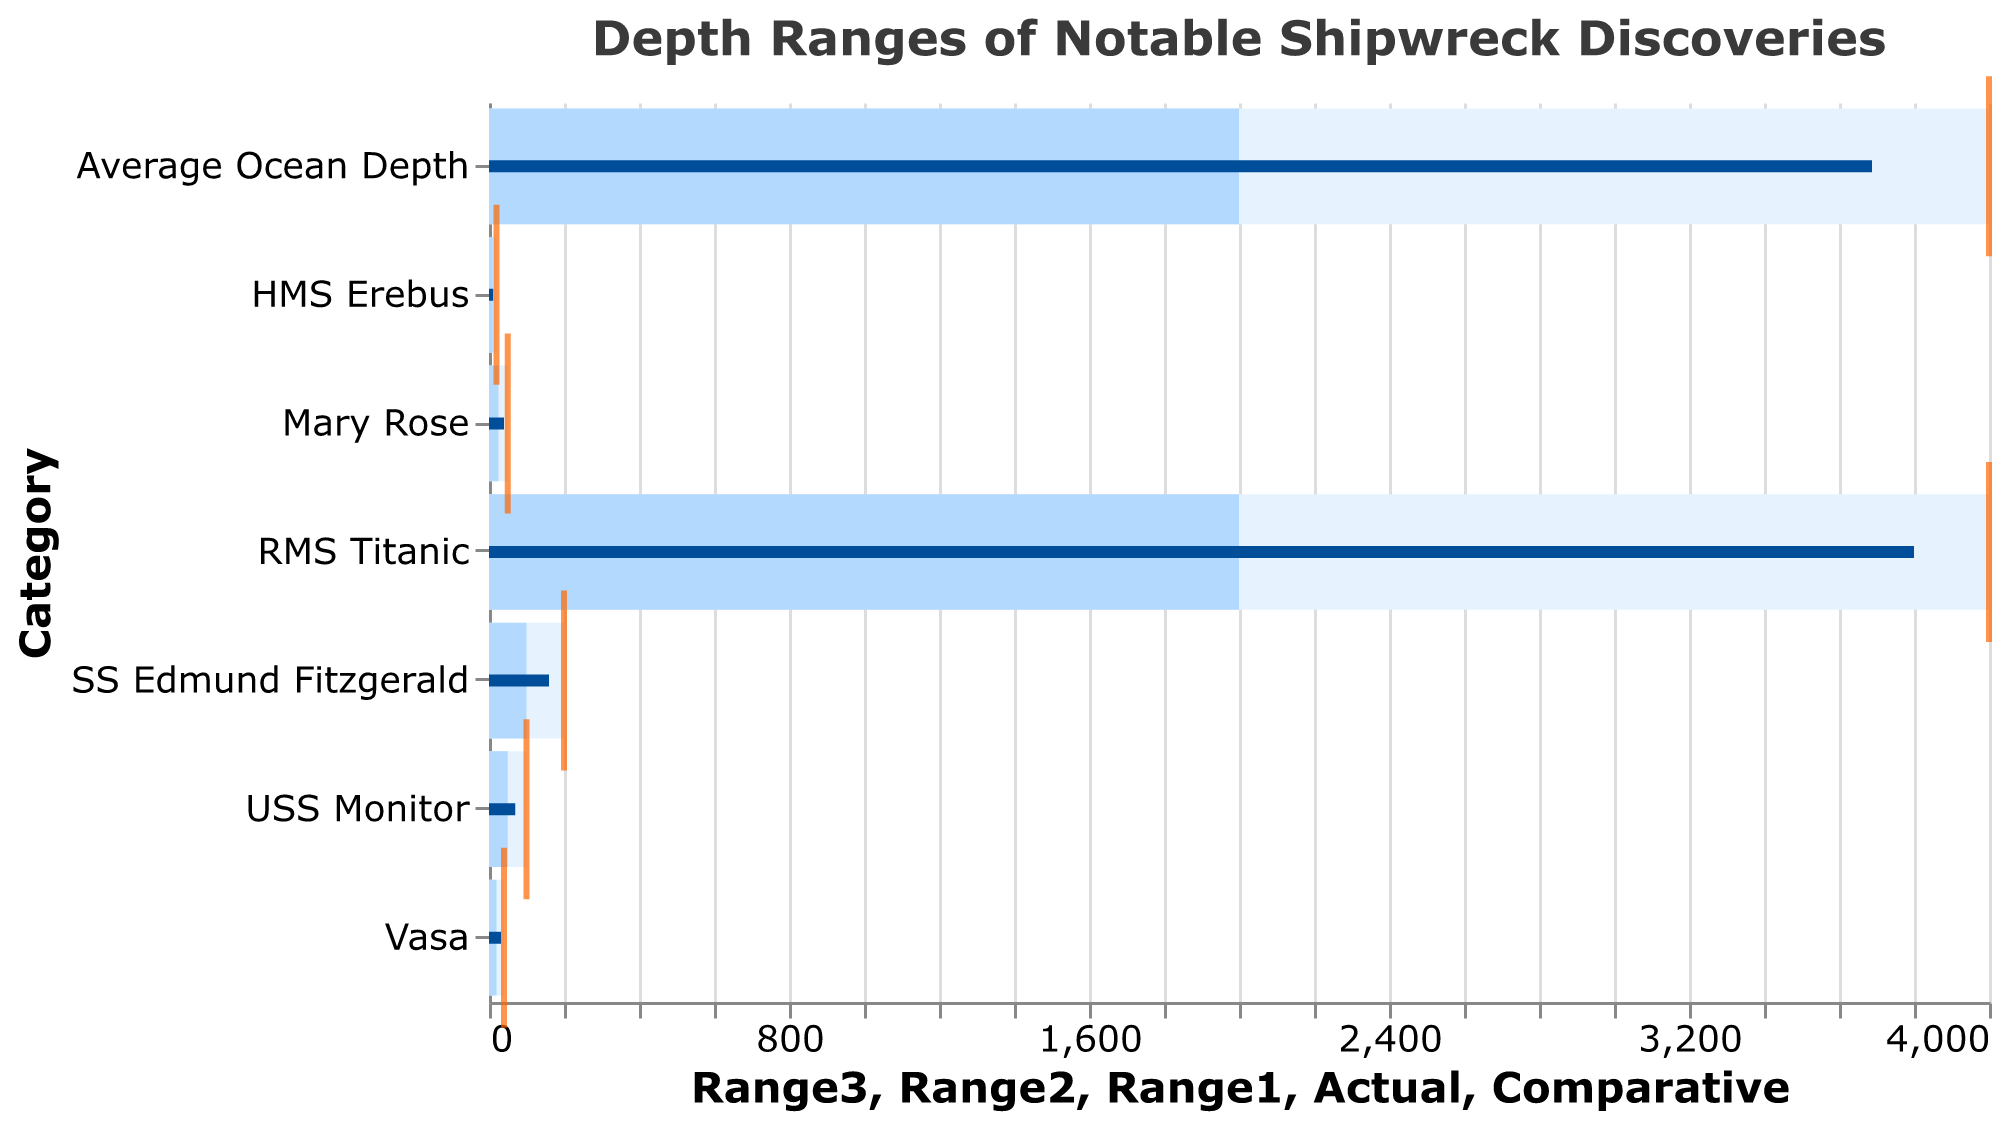What is the title of the figure? The title of the figure is displayed at the top and describes the content being visualized.
Answer: Depth Ranges of Notable Shipwreck Discoveries What is the actual depth of the RMS Titanic's wreck? Look for the "RMS Titanic" category in the figure and check the bar labeled for actual depth.
Answer: 3800 Which shipwreck has the shallowest actual depth? Compare the actual depths of all shipwrecks and find the minimum value. The HMS Erebus has the smallest bar representing its depth.
Answer: HMS Erebus How does the actual depth of the Vasa compare to its comparative depth? Locate the "Vasa" entry and compare the bars. The actual bar reaches 32, and the comparative bar (orange tick) reaches 40.
Answer: The actual depth of the Vasa is 8 meters less than its comparative depth What is the range of depths for the SS Edmund Fitzgerald? Identify the "SS Edmund Fitzgerald" and look at the bars. The range is represented by the lightest blue bar, spanning from 0 to 200 meters.
Answer: 0 to 200 meters Which shipwreck lies deeper than the average ocean depth? Compare the individual shipwreck bars to the "Average Ocean Depth" bar. The "RMS Titanic" has an actual depth (3800) greater than the average ocean depth (3688).
Answer: RMS Titanic For shipwrecks with a lower comparative depth than the RMS Titanic's actual depth, what is the common characteristic? Look for shipwrecks with a comparative depth less than 3800. Each has a lower actual depth than the RMS Titanic, indicating a similar shallower wreck compared to the RMS Titanic.
Answer: All have shallower actual depths than the RMS Titanic Which shipwreck lies at nearly half the depth of the average ocean depth? Find the shipwreck whose actual depth is close to half the average ocean depth of 3688 (half is approximately 1844). None of the individual shipwrecks meet this criterion precisely.
Answer: None What is the difference between the comparative depth and the actual depth of the USS Monitor? Subtract the actual depth (70) from the comparative depth (100) for the USS Monitor.
Answer: 30 meters How many shipwrecks have an actual depth within the first depth range? Count the number of shipwrecks where the actual depth falls within the first range (lightest blue bar). These are: USS Monitor, Mary Rose, Vasa, SS Edmund Fitzgerald, and HMS Erebus.
Answer: 5 shipwrecks 